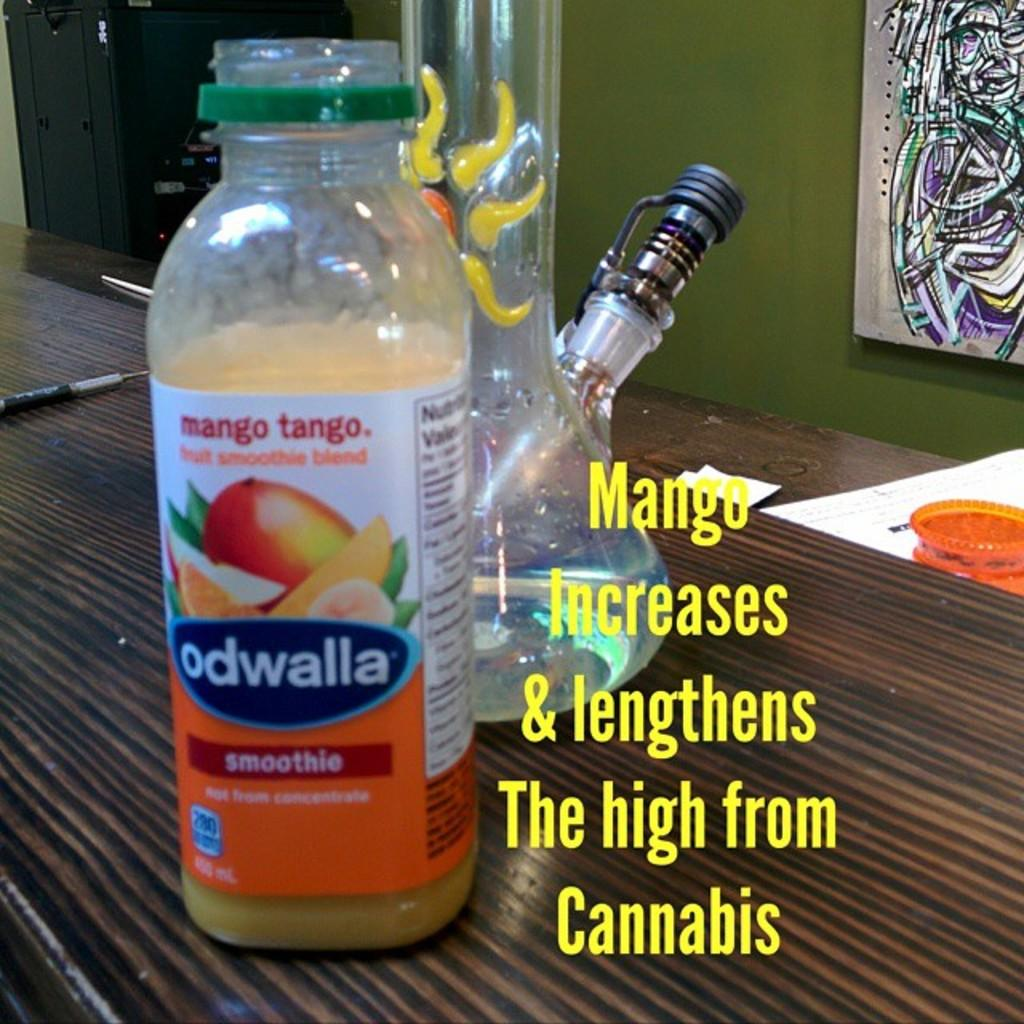<image>
Present a compact description of the photo's key features. A bottle of mango tango smoothie by odwalla 